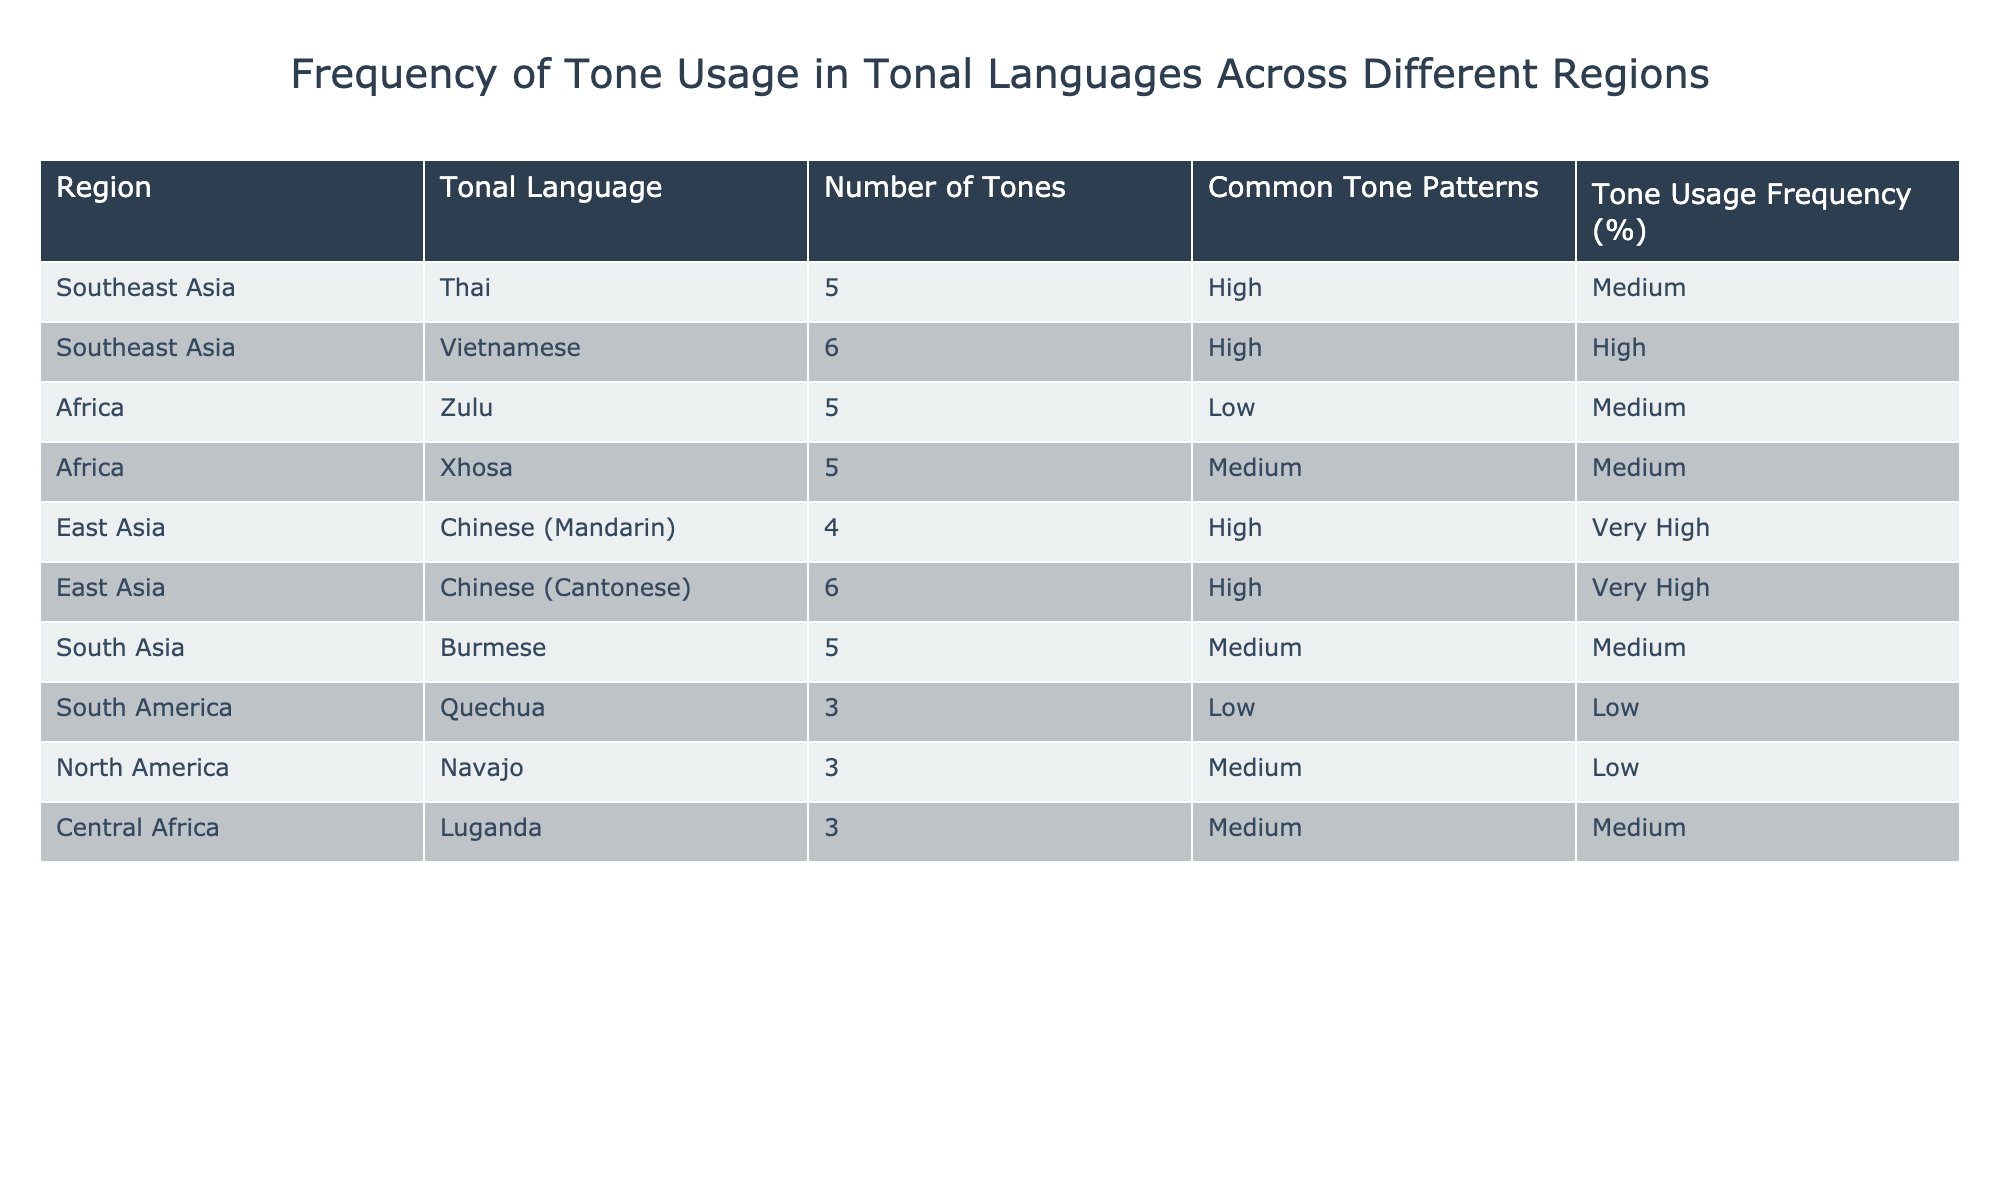What region has the tonal language with the highest number of tones? In the table, we see that Vietnamese from Southeast Asia has the highest number of tones, which is 6.
Answer: Southeast Asia How many tonal languages are listed for Africa? The table shows two tonal languages from Africa: Zulu and Xhosa.
Answer: 2 Which tonal language has a medium frequency of tone usage? Looking through the table, Luganda and Burmese both have a medium frequency of tone usage.
Answer: Luganda, Burmese Do any of the tonal languages in South America have a high tone usage frequency? The table indicates that Quechua has a low tone usage frequency, meaning no tonal languages in South America have high frequency usage.
Answer: No What is the average number of tones for the tonal languages in East Asia? The languages listed in East Asia are Chinese (Mandarin) with 4 tones and Chinese (Cantonese) with 6 tones. The average is (4 + 6)/2 = 5 tones.
Answer: 5 Is the frequency of tone usage high for any tonal languages in Southeast Asia? Yes, Vietnamese has a high frequency of tone usage according to the table.
Answer: Yes Which region features tonal languages with a very high frequency of tone usage? The table shows that both Chinese (Mandarin) and Chinese (Cantonese) from East Asia have a very high frequency of tone usage.
Answer: East Asia What is the total number of tones for all the tonal languages from South Asia? Burmese is the only tonal language listed for South Asia, with a total of 5 tones. Thus, the total number of tones is 5.
Answer: 5 Among the languages listed, which has the lowest number of tones? Quechua is the tonal language with the lowest number of tones, which is 3.
Answer: Quechua 